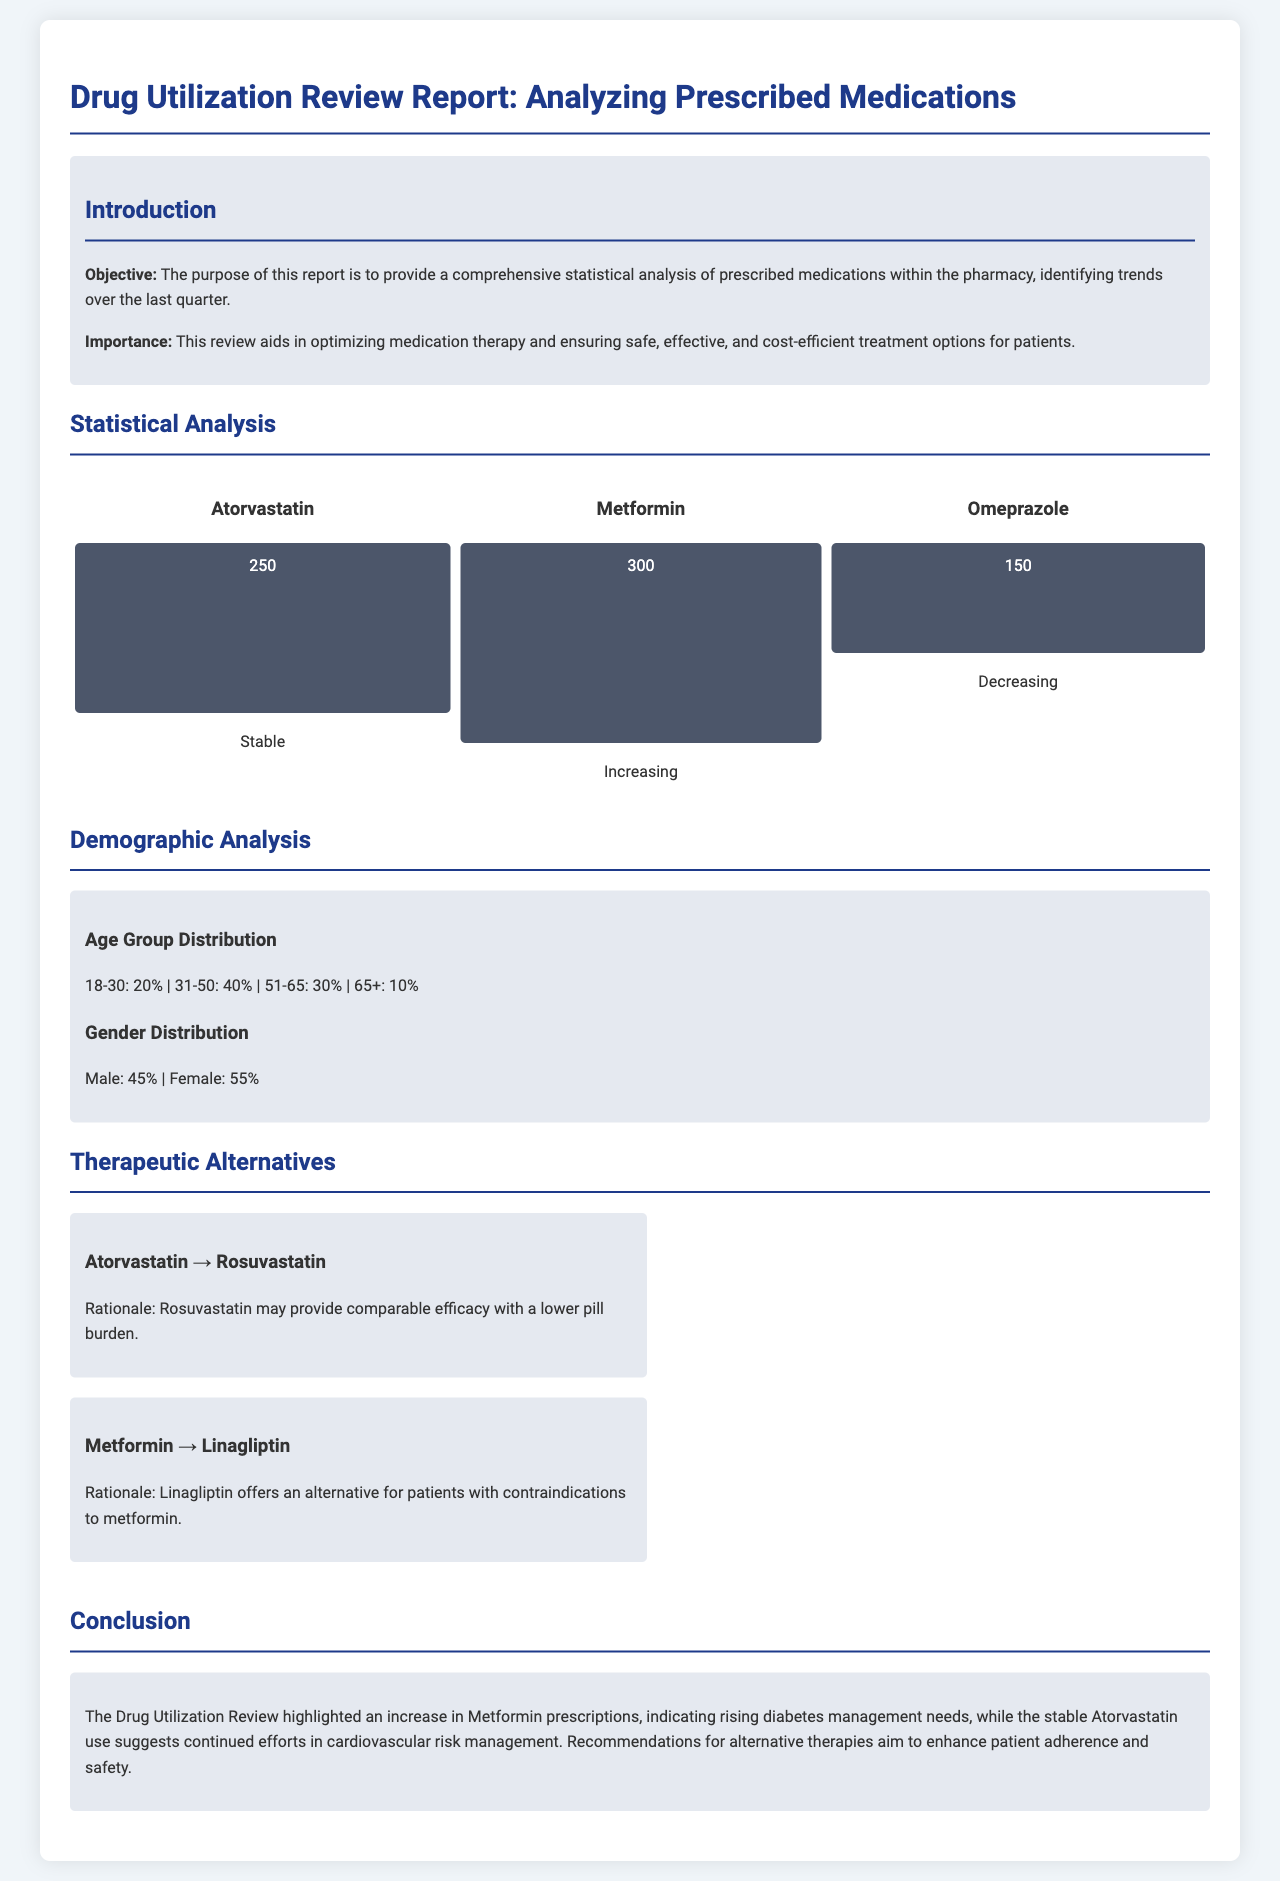What is the objective of the report? The objective of the report is to provide a comprehensive statistical analysis of prescribed medications within the pharmacy.
Answer: Comprehensive statistical analysis of prescribed medications What percentage of prescriptions are for patients aged 31-50? The document provides demographic information, stating that 40% of prescriptions are for patients aged 31-50.
Answer: 40% What medication has the highest prescription number? According to the trend chart, Metformin has the highest prescribed medications at 300.
Answer: 300 What is the trend for Omeprazole prescriptions? The report describes Omeprazole prescriptions as "Decreasing," indicating a downward trend in usage.
Answer: Decreasing Which medication is recommended as an alternative to Atorvastatin? The report recommends Rosuvastatin as an alternative therapy for Atorvastatin.
Answer: Rosuvastatin What is the rationale for recommending Linagliptin? The document states that Linagliptin offers an alternative for patients with contraindications to metformin.
Answer: Patients with contraindications to metformin How many total age groups are analyzed? The document lists four age groups for analysis: 18-30, 31-50, 51-65, and 65+.
Answer: Four What is the total percentage of female patients? The document states that female patients account for 55% of the demographic analysis.
Answer: 55% What is one conclusion drawn in the report? The report concludes that the Drug Utilization Review highlighted an increase in Metformin prescriptions.
Answer: Increase in Metformin prescriptions 